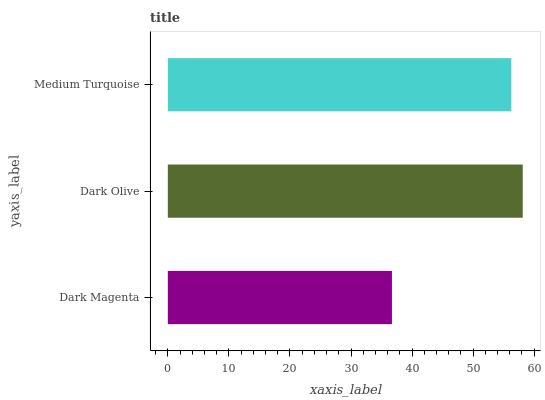Is Dark Magenta the minimum?
Answer yes or no. Yes. Is Dark Olive the maximum?
Answer yes or no. Yes. Is Medium Turquoise the minimum?
Answer yes or no. No. Is Medium Turquoise the maximum?
Answer yes or no. No. Is Dark Olive greater than Medium Turquoise?
Answer yes or no. Yes. Is Medium Turquoise less than Dark Olive?
Answer yes or no. Yes. Is Medium Turquoise greater than Dark Olive?
Answer yes or no. No. Is Dark Olive less than Medium Turquoise?
Answer yes or no. No. Is Medium Turquoise the high median?
Answer yes or no. Yes. Is Medium Turquoise the low median?
Answer yes or no. Yes. Is Dark Olive the high median?
Answer yes or no. No. Is Dark Olive the low median?
Answer yes or no. No. 